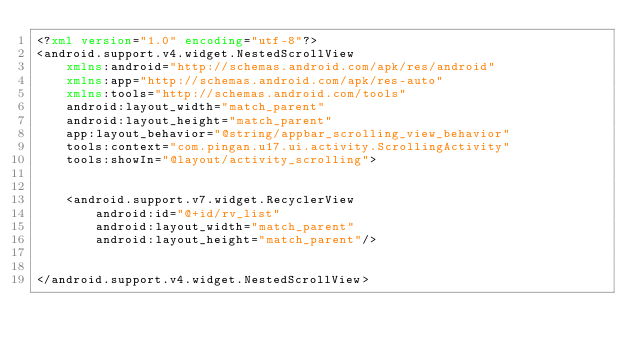<code> <loc_0><loc_0><loc_500><loc_500><_XML_><?xml version="1.0" encoding="utf-8"?>
<android.support.v4.widget.NestedScrollView
    xmlns:android="http://schemas.android.com/apk/res/android"
    xmlns:app="http://schemas.android.com/apk/res-auto"
    xmlns:tools="http://schemas.android.com/tools"
    android:layout_width="match_parent"
    android:layout_height="match_parent"
    app:layout_behavior="@string/appbar_scrolling_view_behavior"
    tools:context="com.pingan.u17.ui.activity.ScrollingActivity"
    tools:showIn="@layout/activity_scrolling">


    <android.support.v7.widget.RecyclerView
        android:id="@+id/rv_list"
        android:layout_width="match_parent"
        android:layout_height="match_parent"/>


</android.support.v4.widget.NestedScrollView>
</code> 